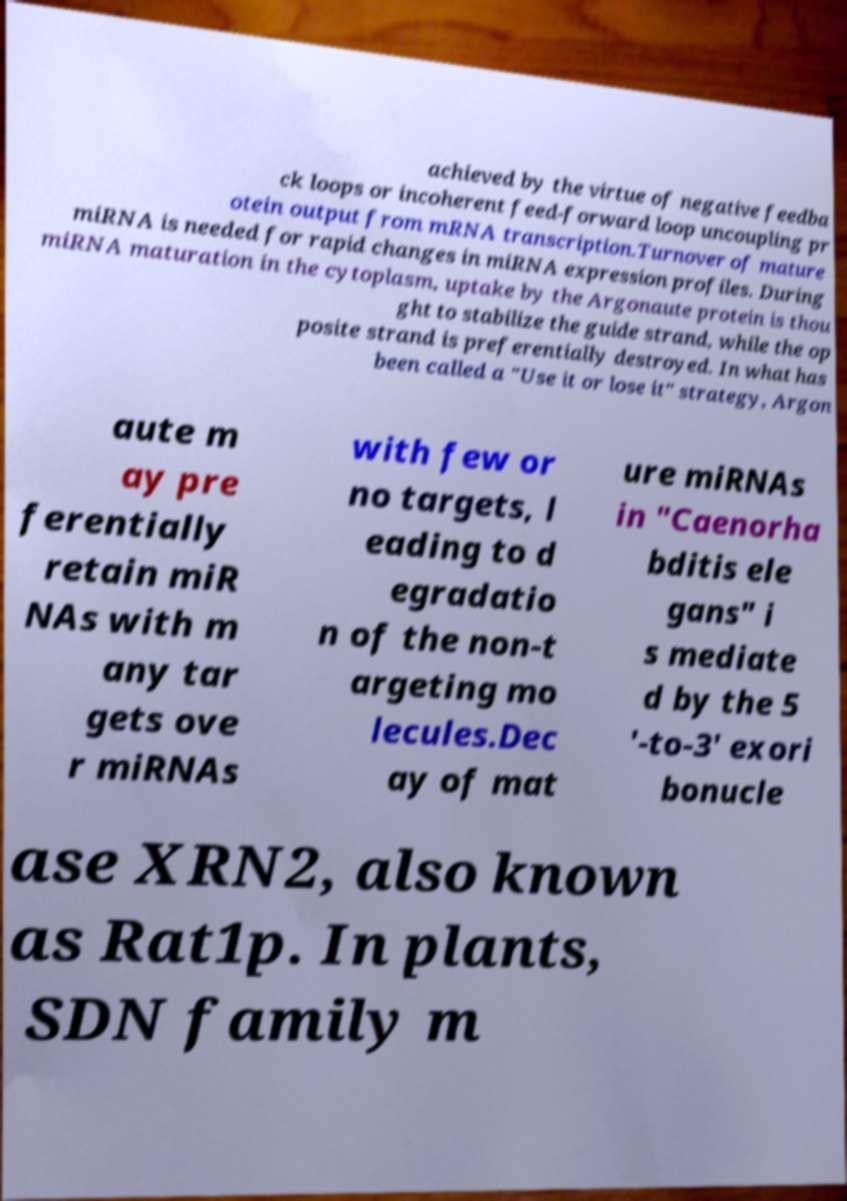Could you extract and type out the text from this image? achieved by the virtue of negative feedba ck loops or incoherent feed-forward loop uncoupling pr otein output from mRNA transcription.Turnover of mature miRNA is needed for rapid changes in miRNA expression profiles. During miRNA maturation in the cytoplasm, uptake by the Argonaute protein is thou ght to stabilize the guide strand, while the op posite strand is preferentially destroyed. In what has been called a "Use it or lose it" strategy, Argon aute m ay pre ferentially retain miR NAs with m any tar gets ove r miRNAs with few or no targets, l eading to d egradatio n of the non-t argeting mo lecules.Dec ay of mat ure miRNAs in "Caenorha bditis ele gans" i s mediate d by the 5 '-to-3' exori bonucle ase XRN2, also known as Rat1p. In plants, SDN family m 